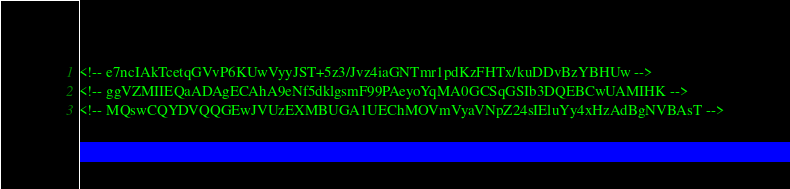<code> <loc_0><loc_0><loc_500><loc_500><_XML_><!-- e7ncIAkTcetqGVvP6KUwVyyJST+5z3/Jvz4iaGNTmr1pdKzFHTx/kuDDvBzYBHUw -->
<!-- ggVZMIIEQaADAgECAhA9eNf5dklgsmF99PAeyoYqMA0GCSqGSIb3DQEBCwUAMIHK -->
<!-- MQswCQYDVQQGEwJVUzEXMBUGA1UEChMOVmVyaVNpZ24sIEluYy4xHzAdBgNVBAsT --></code> 